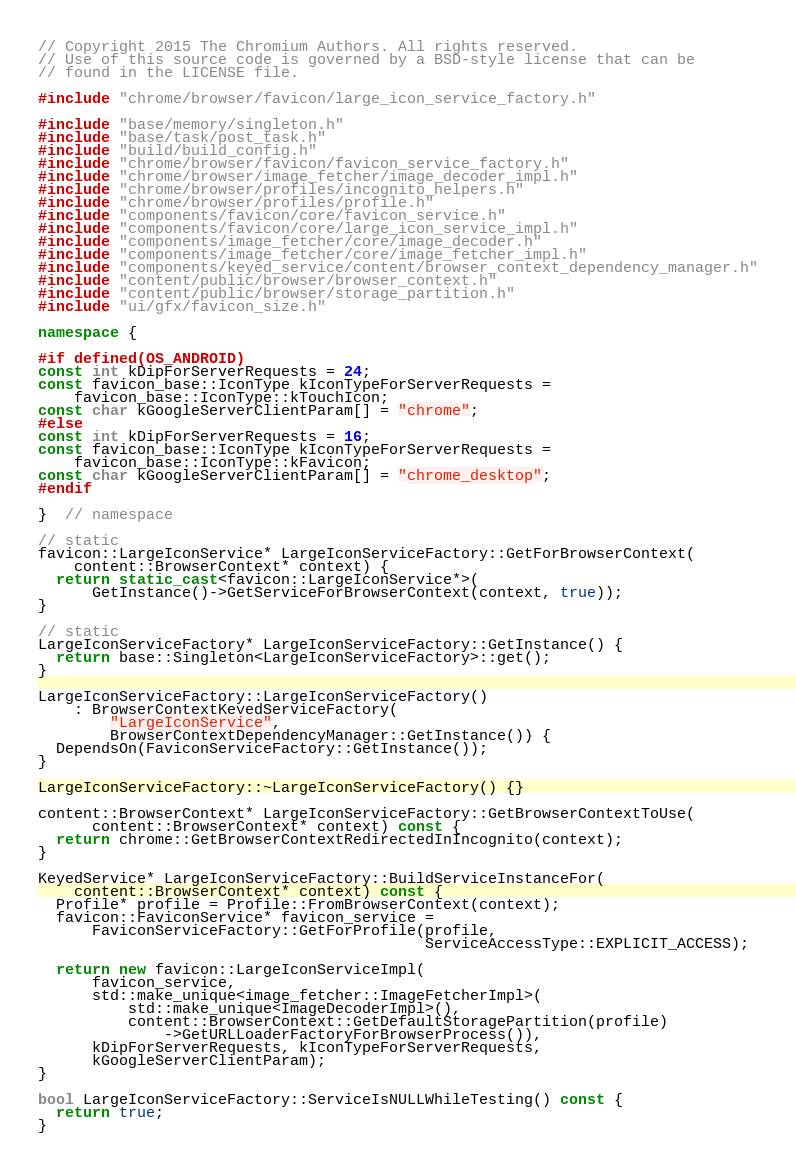Convert code to text. <code><loc_0><loc_0><loc_500><loc_500><_C++_>// Copyright 2015 The Chromium Authors. All rights reserved.
// Use of this source code is governed by a BSD-style license that can be
// found in the LICENSE file.

#include "chrome/browser/favicon/large_icon_service_factory.h"

#include "base/memory/singleton.h"
#include "base/task/post_task.h"
#include "build/build_config.h"
#include "chrome/browser/favicon/favicon_service_factory.h"
#include "chrome/browser/image_fetcher/image_decoder_impl.h"
#include "chrome/browser/profiles/incognito_helpers.h"
#include "chrome/browser/profiles/profile.h"
#include "components/favicon/core/favicon_service.h"
#include "components/favicon/core/large_icon_service_impl.h"
#include "components/image_fetcher/core/image_decoder.h"
#include "components/image_fetcher/core/image_fetcher_impl.h"
#include "components/keyed_service/content/browser_context_dependency_manager.h"
#include "content/public/browser/browser_context.h"
#include "content/public/browser/storage_partition.h"
#include "ui/gfx/favicon_size.h"

namespace {

#if defined(OS_ANDROID)
const int kDipForServerRequests = 24;
const favicon_base::IconType kIconTypeForServerRequests =
    favicon_base::IconType::kTouchIcon;
const char kGoogleServerClientParam[] = "chrome";
#else
const int kDipForServerRequests = 16;
const favicon_base::IconType kIconTypeForServerRequests =
    favicon_base::IconType::kFavicon;
const char kGoogleServerClientParam[] = "chrome_desktop";
#endif

}  // namespace

// static
favicon::LargeIconService* LargeIconServiceFactory::GetForBrowserContext(
    content::BrowserContext* context) {
  return static_cast<favicon::LargeIconService*>(
      GetInstance()->GetServiceForBrowserContext(context, true));
}

// static
LargeIconServiceFactory* LargeIconServiceFactory::GetInstance() {
  return base::Singleton<LargeIconServiceFactory>::get();
}

LargeIconServiceFactory::LargeIconServiceFactory()
    : BrowserContextKeyedServiceFactory(
        "LargeIconService",
        BrowserContextDependencyManager::GetInstance()) {
  DependsOn(FaviconServiceFactory::GetInstance());
}

LargeIconServiceFactory::~LargeIconServiceFactory() {}

content::BrowserContext* LargeIconServiceFactory::GetBrowserContextToUse(
      content::BrowserContext* context) const {
  return chrome::GetBrowserContextRedirectedInIncognito(context);
}

KeyedService* LargeIconServiceFactory::BuildServiceInstanceFor(
    content::BrowserContext* context) const {
  Profile* profile = Profile::FromBrowserContext(context);
  favicon::FaviconService* favicon_service =
      FaviconServiceFactory::GetForProfile(profile,
                                           ServiceAccessType::EXPLICIT_ACCESS);

  return new favicon::LargeIconServiceImpl(
      favicon_service,
      std::make_unique<image_fetcher::ImageFetcherImpl>(
          std::make_unique<ImageDecoderImpl>(),
          content::BrowserContext::GetDefaultStoragePartition(profile)
              ->GetURLLoaderFactoryForBrowserProcess()),
      kDipForServerRequests, kIconTypeForServerRequests,
      kGoogleServerClientParam);
}

bool LargeIconServiceFactory::ServiceIsNULLWhileTesting() const {
  return true;
}
</code> 